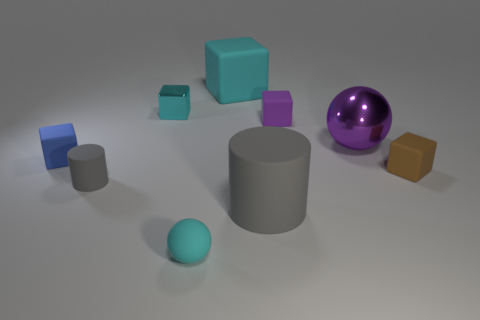There is a ball on the left side of the matte object behind the cyan metal block; how big is it? The ball on the left side of the matte object and behind the cyan metal block appears to be of medium size relative to the other objects in the scene. It is not the largest nor the smallest object presented. 